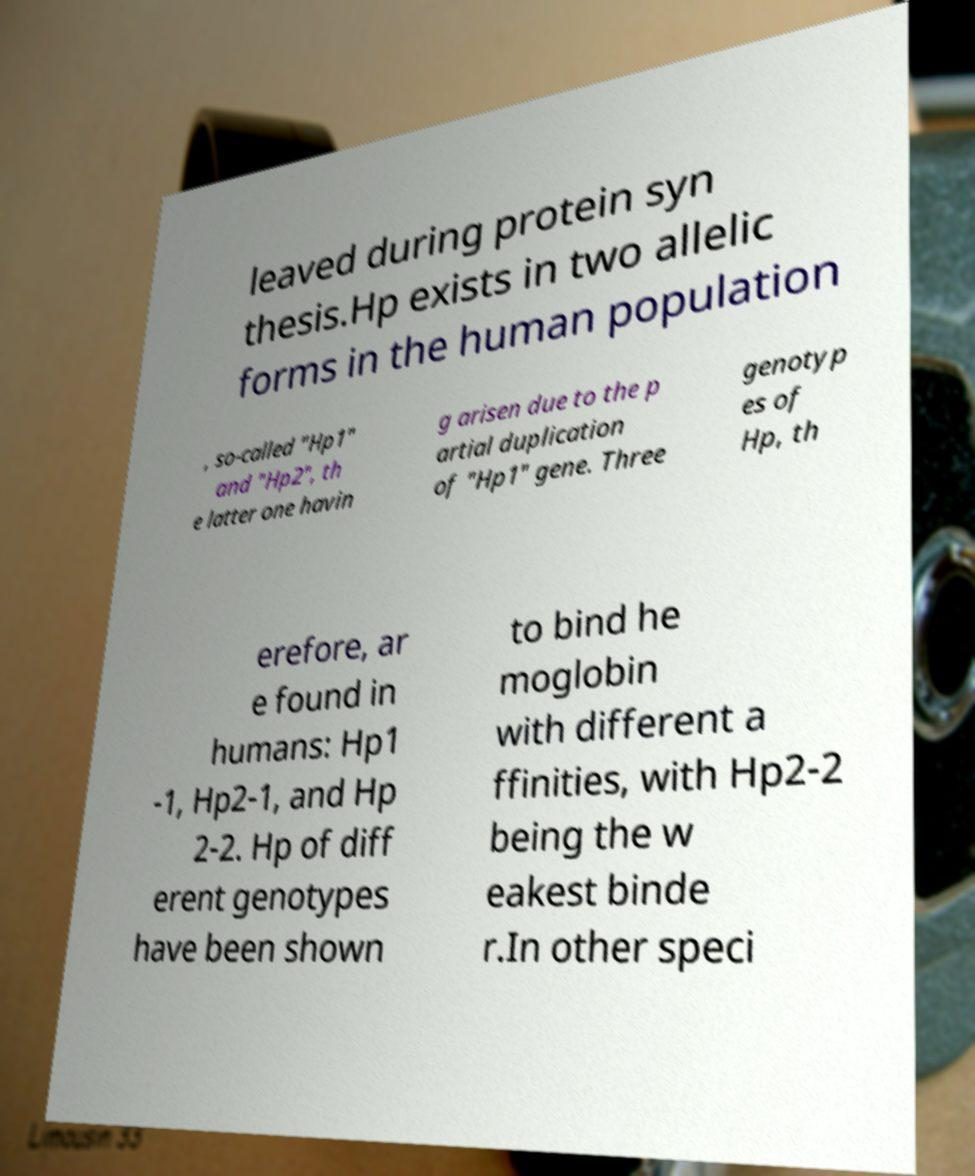Could you extract and type out the text from this image? leaved during protein syn thesis.Hp exists in two allelic forms in the human population , so-called "Hp1" and "Hp2", th e latter one havin g arisen due to the p artial duplication of "Hp1" gene. Three genotyp es of Hp, th erefore, ar e found in humans: Hp1 -1, Hp2-1, and Hp 2-2. Hp of diff erent genotypes have been shown to bind he moglobin with different a ffinities, with Hp2-2 being the w eakest binde r.In other speci 